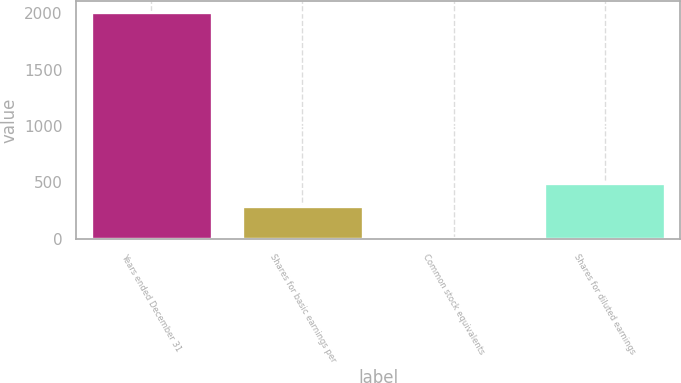Convert chart. <chart><loc_0><loc_0><loc_500><loc_500><bar_chart><fcel>Years ended December 31<fcel>Shares for basic earnings per<fcel>Common stock equivalents<fcel>Shares for diluted earnings<nl><fcel>2008<fcel>292.8<fcel>11.7<fcel>492.43<nl></chart> 